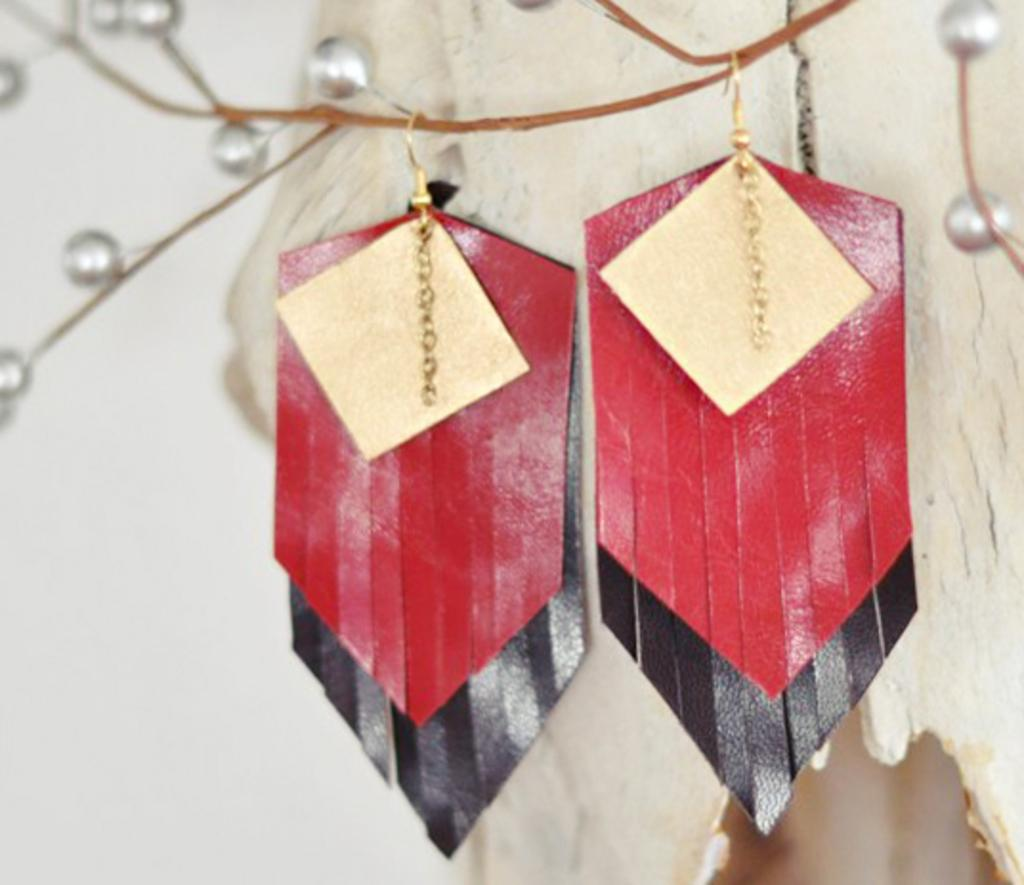What type of accessory is featured in the image? There are earrings in the image. What colors are the earrings? The earrings are in red and black color. What other jewelry item is present in the image? Pearls are present in the image. What is the color of the background in the image? The background of the image is white. What type of business is being conducted in the image? There is no indication of any business activity in the image; it features earrings and pearls. What does the van look like in the image? There is no van present in the image. 